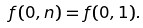<formula> <loc_0><loc_0><loc_500><loc_500>f ( 0 , n ) = f ( 0 , 1 ) .</formula> 